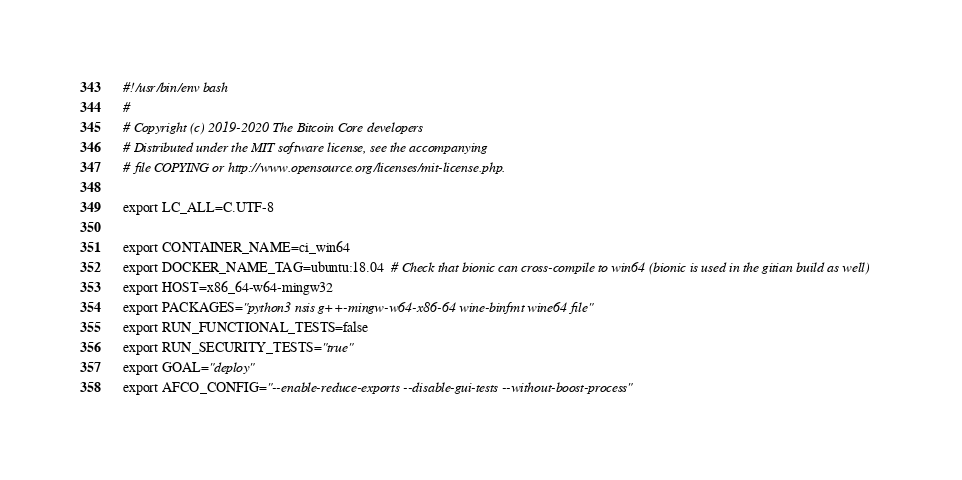<code> <loc_0><loc_0><loc_500><loc_500><_Bash_>#!/usr/bin/env bash
#
# Copyright (c) 2019-2020 The Bitcoin Core developers
# Distributed under the MIT software license, see the accompanying
# file COPYING or http://www.opensource.org/licenses/mit-license.php.

export LC_ALL=C.UTF-8

export CONTAINER_NAME=ci_win64
export DOCKER_NAME_TAG=ubuntu:18.04  # Check that bionic can cross-compile to win64 (bionic is used in the gitian build as well)
export HOST=x86_64-w64-mingw32
export PACKAGES="python3 nsis g++-mingw-w64-x86-64 wine-binfmt wine64 file"
export RUN_FUNCTIONAL_TESTS=false
export RUN_SECURITY_TESTS="true"
export GOAL="deploy"
export AFCO_CONFIG="--enable-reduce-exports --disable-gui-tests --without-boost-process"
</code> 